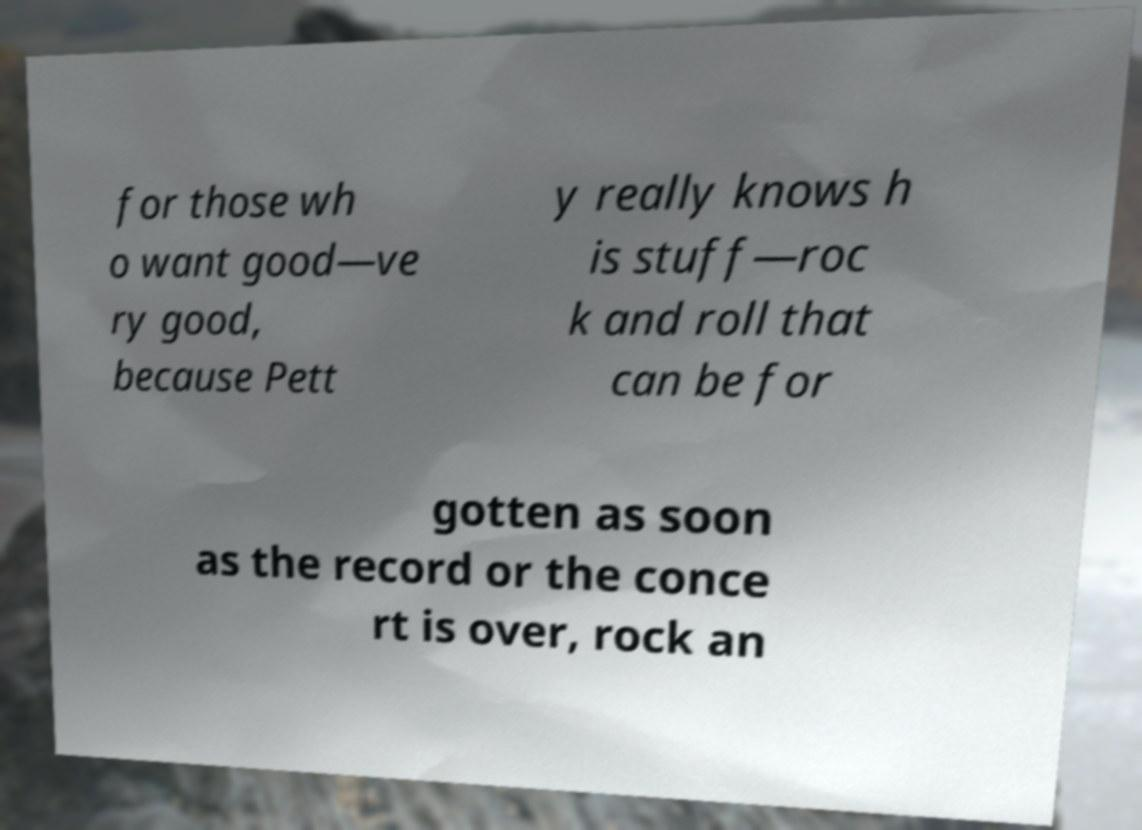Can you read and provide the text displayed in the image?This photo seems to have some interesting text. Can you extract and type it out for me? for those wh o want good—ve ry good, because Pett y really knows h is stuff—roc k and roll that can be for gotten as soon as the record or the conce rt is over, rock an 